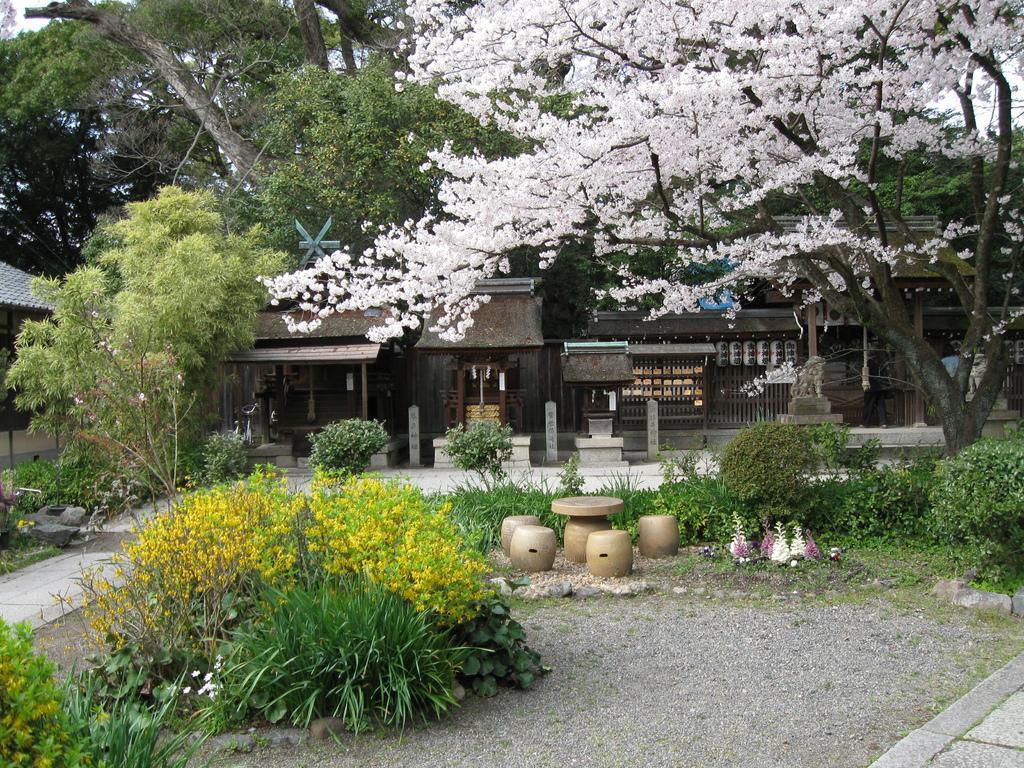Please provide a concise description of this image. In the middle of the image we can see some plants, trees and buildings. 